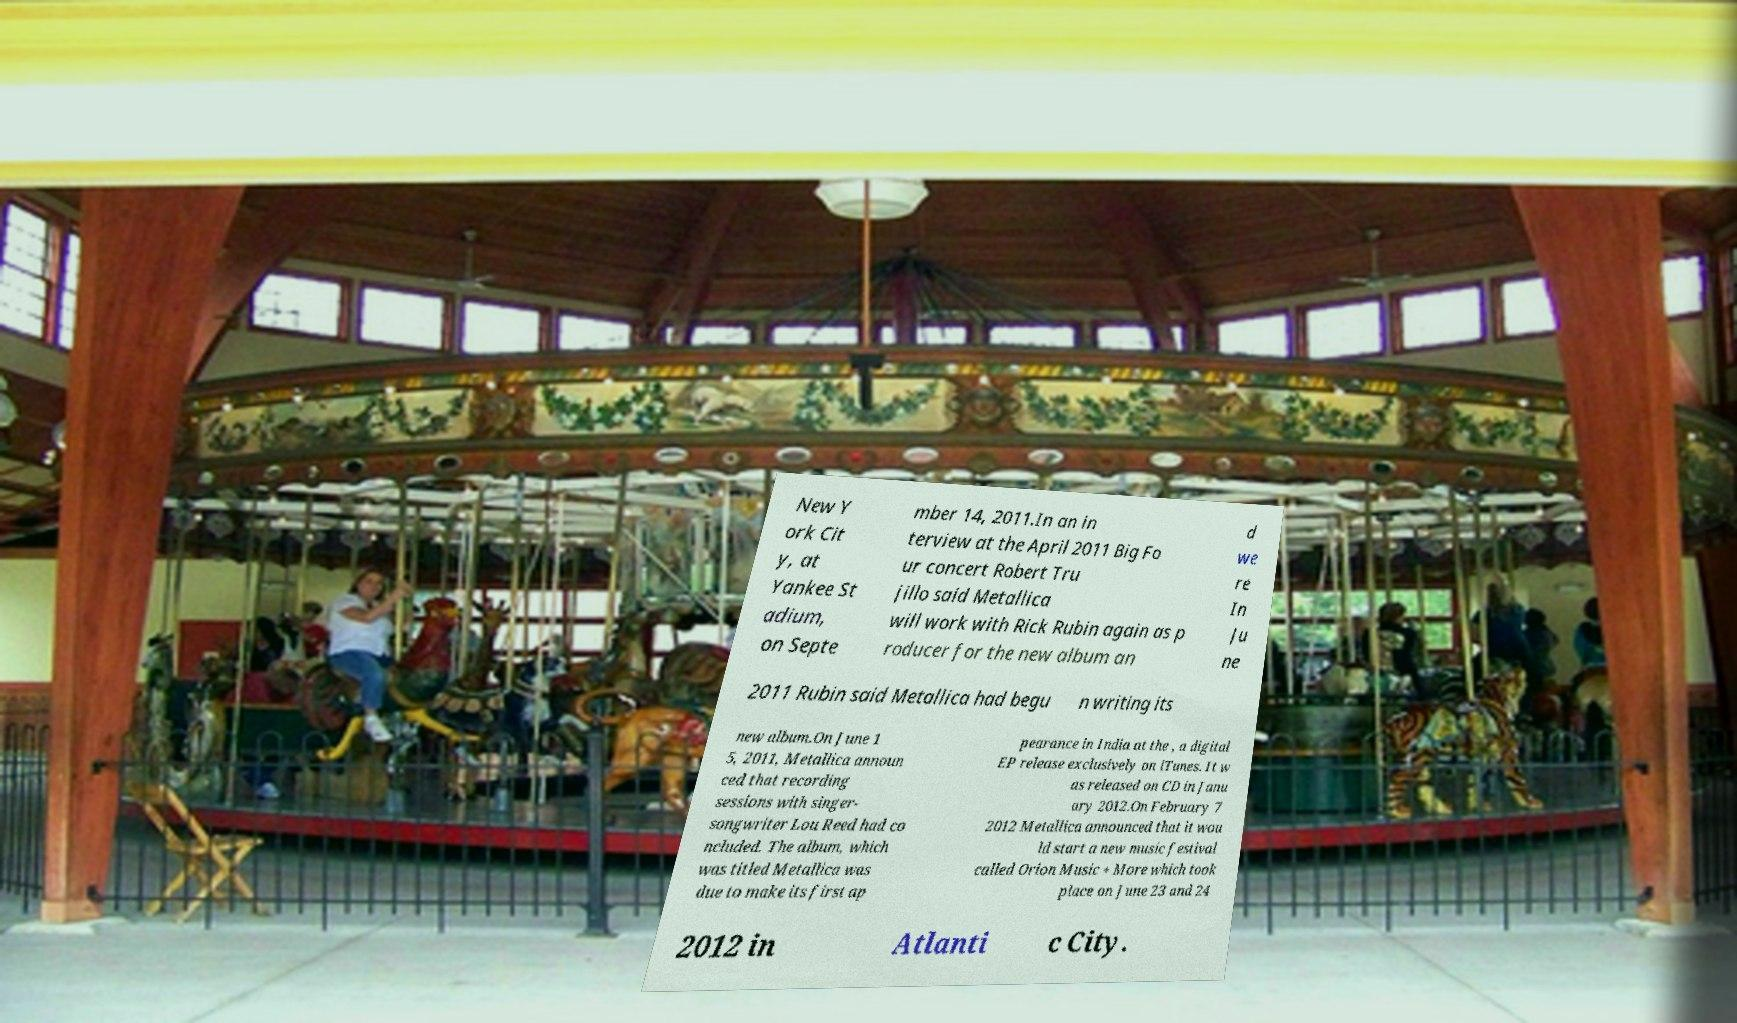For documentation purposes, I need the text within this image transcribed. Could you provide that? New Y ork Cit y, at Yankee St adium, on Septe mber 14, 2011.In an in terview at the April 2011 Big Fo ur concert Robert Tru jillo said Metallica will work with Rick Rubin again as p roducer for the new album an d we re In Ju ne 2011 Rubin said Metallica had begu n writing its new album.On June 1 5, 2011, Metallica announ ced that recording sessions with singer- songwriter Lou Reed had co ncluded. The album, which was titled Metallica was due to make its first ap pearance in India at the , a digital EP release exclusively on iTunes. It w as released on CD in Janu ary 2012.On February 7 2012 Metallica announced that it wou ld start a new music festival called Orion Music + More which took place on June 23 and 24 2012 in Atlanti c City. 